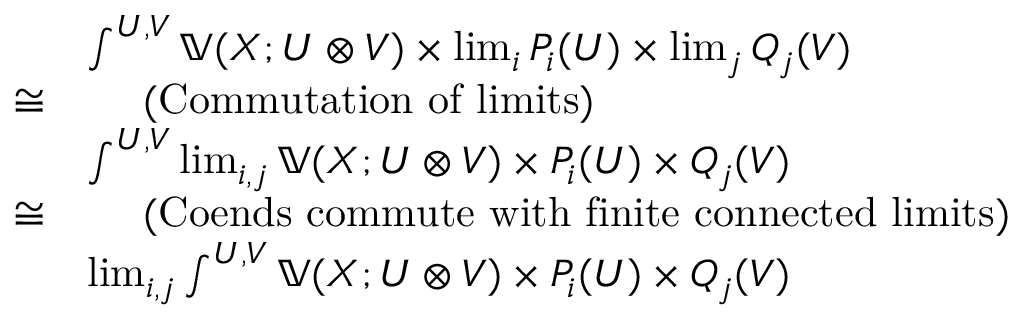Convert formula to latex. <formula><loc_0><loc_0><loc_500><loc_500>\begin{array} { r l } & { \int ^ { U , V } ( X ; U V ) \lim _ { i } P _ { i } ( U ) \lim _ { j } Q _ { j } ( V ) } & { \quad ( C o m m u t a t i o n o f l i m i t s ) } \\ & { \int ^ { U , V } \lim _ { i , j } ( X ; U V ) P _ { i } ( U ) Q _ { j } ( V ) } & { \quad ( C o e n d s c o m m u t e w i t h f i n i t e c o n n e c t e d l i m i t s ) } \\ & { \lim _ { i , j } \int ^ { U , V } ( X ; U V ) P _ { i } ( U ) Q _ { j } ( V ) } \end{array}</formula> 